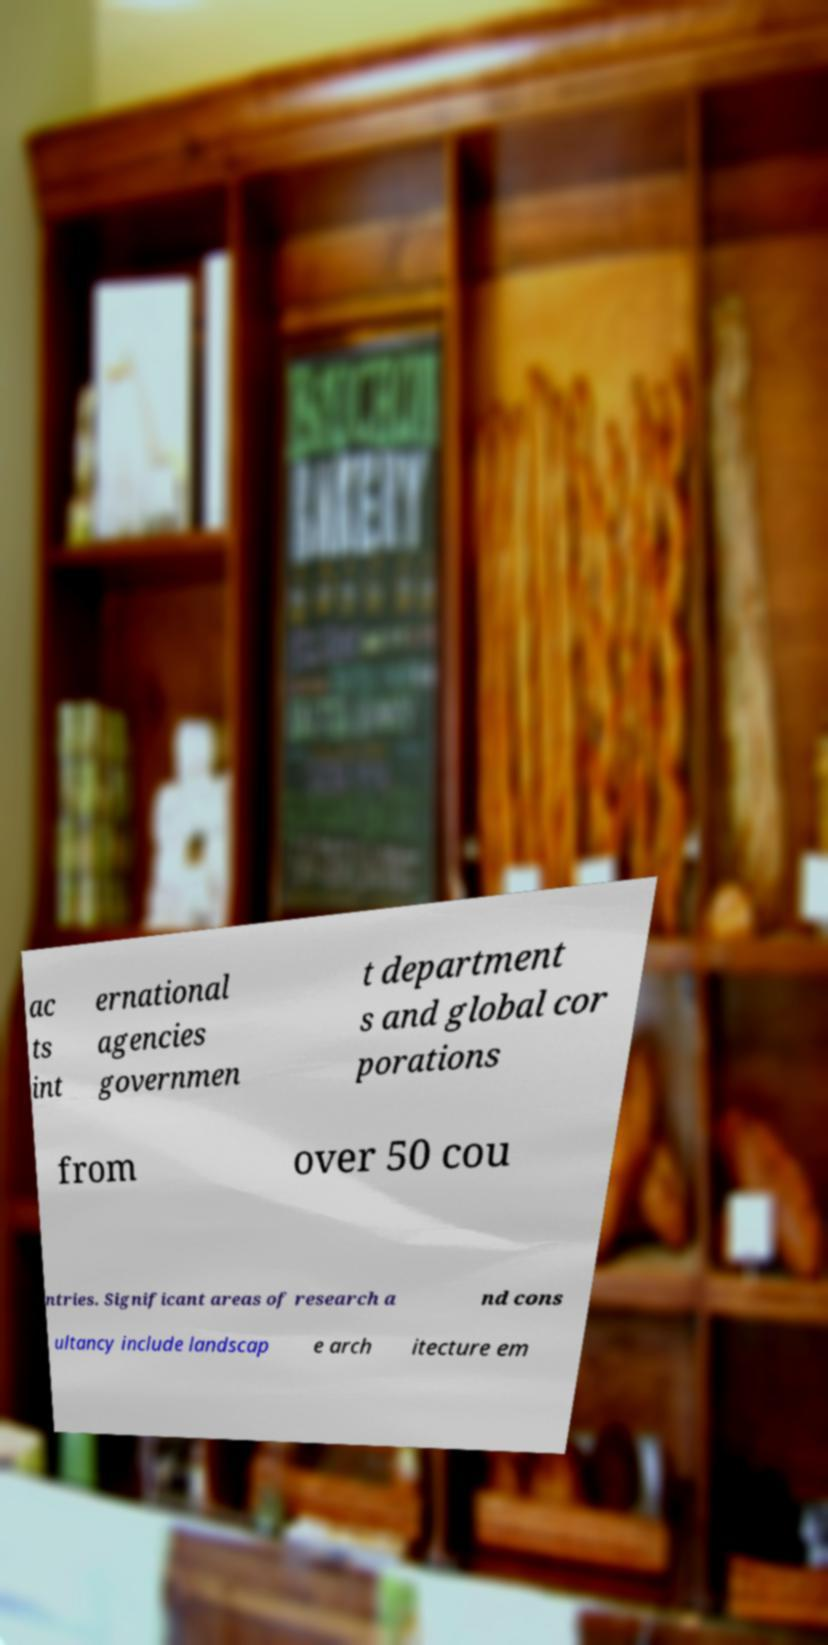I need the written content from this picture converted into text. Can you do that? ac ts int ernational agencies governmen t department s and global cor porations from over 50 cou ntries. Significant areas of research a nd cons ultancy include landscap e arch itecture em 